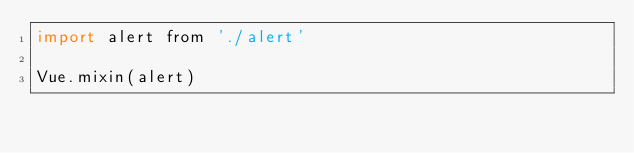<code> <loc_0><loc_0><loc_500><loc_500><_JavaScript_>import alert from './alert'

Vue.mixin(alert)
</code> 